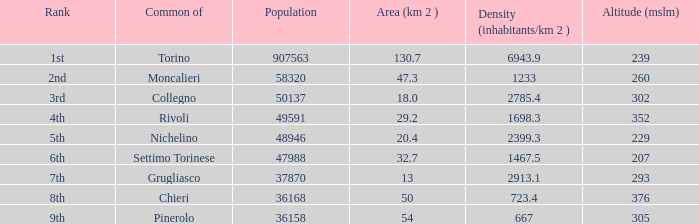What is the title of the 9th ranked ordinary? Pinerolo. 